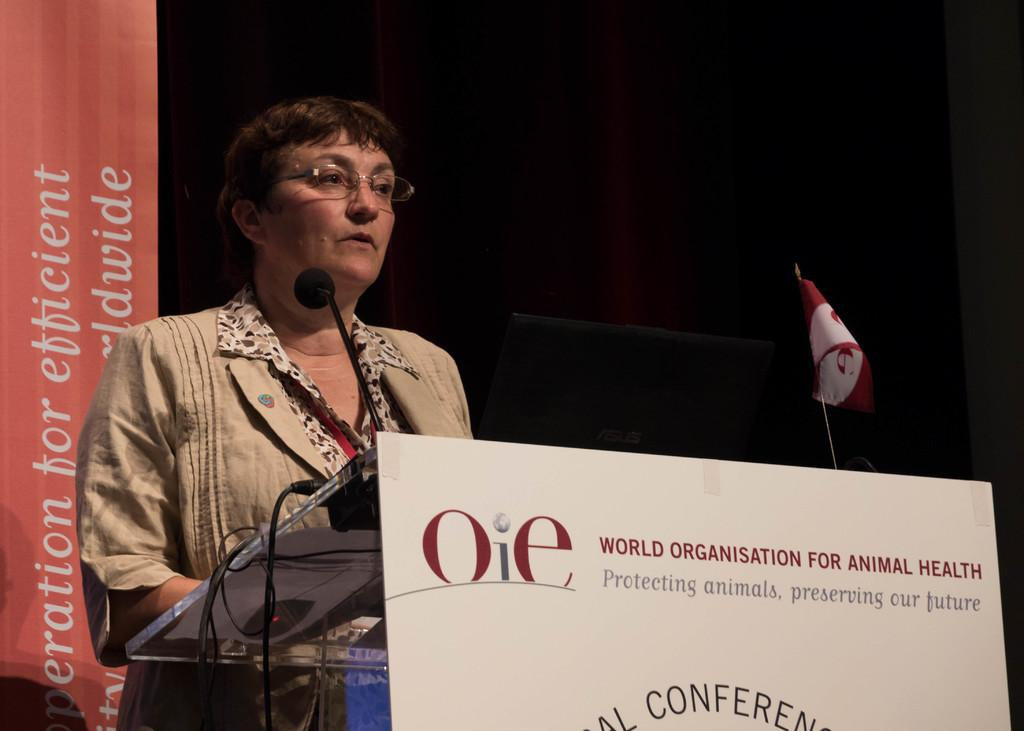Who or what is present in the image? There is a person in the image. What object is visible near the person? There is a microphone in the image. What can be seen on the board in the image? There is written text on a board. What symbol is present in the image? There is a flag in the image. Where can more written text be found in the image? There is written text on the right side of the image. What type of station does the person enjoy visiting in the image? There is no information about a station or the person's preferences in the image. 